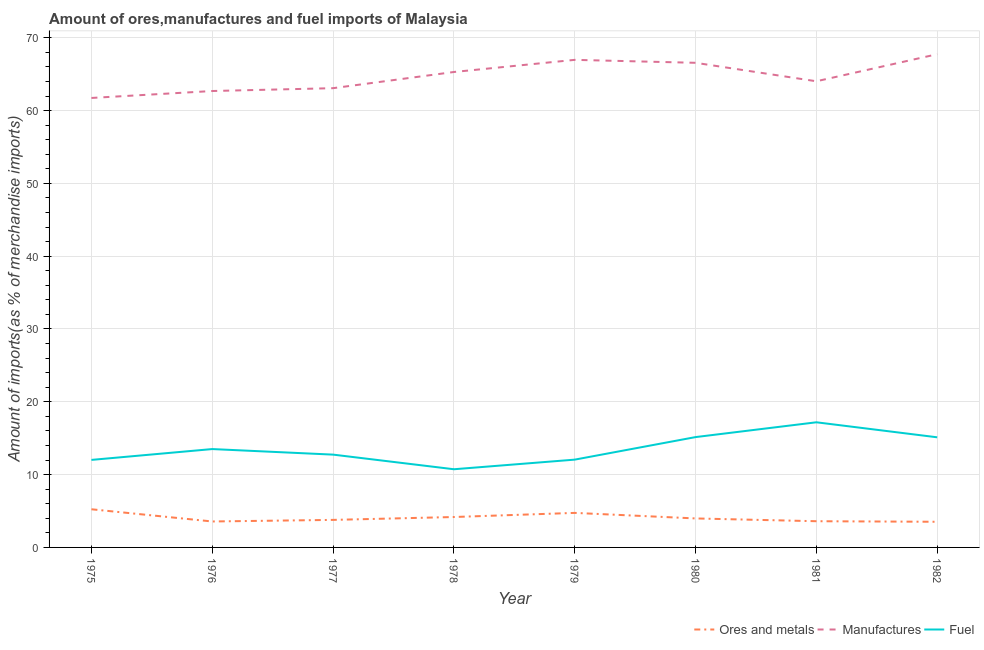What is the percentage of manufactures imports in 1980?
Provide a short and direct response. 66.56. Across all years, what is the maximum percentage of ores and metals imports?
Provide a short and direct response. 5.24. Across all years, what is the minimum percentage of ores and metals imports?
Provide a succinct answer. 3.52. In which year was the percentage of ores and metals imports maximum?
Offer a terse response. 1975. What is the total percentage of ores and metals imports in the graph?
Provide a short and direct response. 32.61. What is the difference between the percentage of fuel imports in 1975 and that in 1978?
Offer a terse response. 1.28. What is the difference between the percentage of fuel imports in 1975 and the percentage of ores and metals imports in 1976?
Provide a short and direct response. 8.46. What is the average percentage of ores and metals imports per year?
Keep it short and to the point. 4.08. In the year 1976, what is the difference between the percentage of fuel imports and percentage of manufactures imports?
Make the answer very short. -49.18. What is the ratio of the percentage of manufactures imports in 1975 to that in 1976?
Provide a short and direct response. 0.98. Is the difference between the percentage of ores and metals imports in 1976 and 1981 greater than the difference between the percentage of manufactures imports in 1976 and 1981?
Ensure brevity in your answer.  Yes. What is the difference between the highest and the second highest percentage of manufactures imports?
Provide a succinct answer. 0.78. What is the difference between the highest and the lowest percentage of ores and metals imports?
Offer a terse response. 1.72. In how many years, is the percentage of manufactures imports greater than the average percentage of manufactures imports taken over all years?
Make the answer very short. 4. Is the sum of the percentage of ores and metals imports in 1978 and 1981 greater than the maximum percentage of manufactures imports across all years?
Offer a very short reply. No. Is it the case that in every year, the sum of the percentage of ores and metals imports and percentage of manufactures imports is greater than the percentage of fuel imports?
Provide a succinct answer. Yes. Is the percentage of fuel imports strictly greater than the percentage of manufactures imports over the years?
Provide a succinct answer. No. Is the percentage of ores and metals imports strictly less than the percentage of manufactures imports over the years?
Give a very brief answer. Yes. What is the difference between two consecutive major ticks on the Y-axis?
Give a very brief answer. 10. How many legend labels are there?
Give a very brief answer. 3. What is the title of the graph?
Provide a succinct answer. Amount of ores,manufactures and fuel imports of Malaysia. What is the label or title of the X-axis?
Make the answer very short. Year. What is the label or title of the Y-axis?
Your answer should be very brief. Amount of imports(as % of merchandise imports). What is the Amount of imports(as % of merchandise imports) in Ores and metals in 1975?
Provide a succinct answer. 5.24. What is the Amount of imports(as % of merchandise imports) in Manufactures in 1975?
Your response must be concise. 61.73. What is the Amount of imports(as % of merchandise imports) of Fuel in 1975?
Give a very brief answer. 12.02. What is the Amount of imports(as % of merchandise imports) of Ores and metals in 1976?
Your answer should be compact. 3.56. What is the Amount of imports(as % of merchandise imports) in Manufactures in 1976?
Offer a terse response. 62.68. What is the Amount of imports(as % of merchandise imports) of Fuel in 1976?
Offer a very short reply. 13.51. What is the Amount of imports(as % of merchandise imports) in Ores and metals in 1977?
Keep it short and to the point. 3.78. What is the Amount of imports(as % of merchandise imports) of Manufactures in 1977?
Provide a succinct answer. 63.07. What is the Amount of imports(as % of merchandise imports) in Fuel in 1977?
Keep it short and to the point. 12.75. What is the Amount of imports(as % of merchandise imports) in Ores and metals in 1978?
Offer a terse response. 4.18. What is the Amount of imports(as % of merchandise imports) of Manufactures in 1978?
Provide a succinct answer. 65.3. What is the Amount of imports(as % of merchandise imports) in Fuel in 1978?
Offer a very short reply. 10.74. What is the Amount of imports(as % of merchandise imports) in Ores and metals in 1979?
Provide a short and direct response. 4.74. What is the Amount of imports(as % of merchandise imports) of Manufactures in 1979?
Your answer should be compact. 66.96. What is the Amount of imports(as % of merchandise imports) in Fuel in 1979?
Your answer should be very brief. 12.06. What is the Amount of imports(as % of merchandise imports) in Ores and metals in 1980?
Keep it short and to the point. 3.98. What is the Amount of imports(as % of merchandise imports) of Manufactures in 1980?
Provide a short and direct response. 66.56. What is the Amount of imports(as % of merchandise imports) in Fuel in 1980?
Give a very brief answer. 15.15. What is the Amount of imports(as % of merchandise imports) of Ores and metals in 1981?
Offer a very short reply. 3.6. What is the Amount of imports(as % of merchandise imports) of Manufactures in 1981?
Your answer should be very brief. 64.02. What is the Amount of imports(as % of merchandise imports) in Fuel in 1981?
Provide a succinct answer. 17.19. What is the Amount of imports(as % of merchandise imports) of Ores and metals in 1982?
Provide a short and direct response. 3.52. What is the Amount of imports(as % of merchandise imports) of Manufactures in 1982?
Keep it short and to the point. 67.74. What is the Amount of imports(as % of merchandise imports) of Fuel in 1982?
Provide a succinct answer. 15.12. Across all years, what is the maximum Amount of imports(as % of merchandise imports) of Ores and metals?
Provide a succinct answer. 5.24. Across all years, what is the maximum Amount of imports(as % of merchandise imports) of Manufactures?
Your answer should be very brief. 67.74. Across all years, what is the maximum Amount of imports(as % of merchandise imports) in Fuel?
Keep it short and to the point. 17.19. Across all years, what is the minimum Amount of imports(as % of merchandise imports) of Ores and metals?
Ensure brevity in your answer.  3.52. Across all years, what is the minimum Amount of imports(as % of merchandise imports) in Manufactures?
Give a very brief answer. 61.73. Across all years, what is the minimum Amount of imports(as % of merchandise imports) of Fuel?
Make the answer very short. 10.74. What is the total Amount of imports(as % of merchandise imports) in Ores and metals in the graph?
Your answer should be very brief. 32.61. What is the total Amount of imports(as % of merchandise imports) of Manufactures in the graph?
Ensure brevity in your answer.  518.08. What is the total Amount of imports(as % of merchandise imports) in Fuel in the graph?
Keep it short and to the point. 108.54. What is the difference between the Amount of imports(as % of merchandise imports) of Ores and metals in 1975 and that in 1976?
Provide a short and direct response. 1.68. What is the difference between the Amount of imports(as % of merchandise imports) in Manufactures in 1975 and that in 1976?
Make the answer very short. -0.95. What is the difference between the Amount of imports(as % of merchandise imports) of Fuel in 1975 and that in 1976?
Ensure brevity in your answer.  -1.49. What is the difference between the Amount of imports(as % of merchandise imports) of Ores and metals in 1975 and that in 1977?
Give a very brief answer. 1.46. What is the difference between the Amount of imports(as % of merchandise imports) in Manufactures in 1975 and that in 1977?
Your response must be concise. -1.34. What is the difference between the Amount of imports(as % of merchandise imports) in Fuel in 1975 and that in 1977?
Your answer should be compact. -0.72. What is the difference between the Amount of imports(as % of merchandise imports) in Ores and metals in 1975 and that in 1978?
Your answer should be very brief. 1.06. What is the difference between the Amount of imports(as % of merchandise imports) in Manufactures in 1975 and that in 1978?
Keep it short and to the point. -3.57. What is the difference between the Amount of imports(as % of merchandise imports) of Fuel in 1975 and that in 1978?
Your response must be concise. 1.28. What is the difference between the Amount of imports(as % of merchandise imports) in Ores and metals in 1975 and that in 1979?
Ensure brevity in your answer.  0.5. What is the difference between the Amount of imports(as % of merchandise imports) in Manufactures in 1975 and that in 1979?
Ensure brevity in your answer.  -5.23. What is the difference between the Amount of imports(as % of merchandise imports) of Fuel in 1975 and that in 1979?
Offer a very short reply. -0.04. What is the difference between the Amount of imports(as % of merchandise imports) of Ores and metals in 1975 and that in 1980?
Ensure brevity in your answer.  1.26. What is the difference between the Amount of imports(as % of merchandise imports) in Manufactures in 1975 and that in 1980?
Provide a short and direct response. -4.83. What is the difference between the Amount of imports(as % of merchandise imports) in Fuel in 1975 and that in 1980?
Make the answer very short. -3.13. What is the difference between the Amount of imports(as % of merchandise imports) of Ores and metals in 1975 and that in 1981?
Offer a very short reply. 1.64. What is the difference between the Amount of imports(as % of merchandise imports) in Manufactures in 1975 and that in 1981?
Keep it short and to the point. -2.29. What is the difference between the Amount of imports(as % of merchandise imports) of Fuel in 1975 and that in 1981?
Give a very brief answer. -5.16. What is the difference between the Amount of imports(as % of merchandise imports) in Ores and metals in 1975 and that in 1982?
Your response must be concise. 1.72. What is the difference between the Amount of imports(as % of merchandise imports) of Manufactures in 1975 and that in 1982?
Offer a terse response. -6.01. What is the difference between the Amount of imports(as % of merchandise imports) in Fuel in 1975 and that in 1982?
Provide a succinct answer. -3.1. What is the difference between the Amount of imports(as % of merchandise imports) of Ores and metals in 1976 and that in 1977?
Ensure brevity in your answer.  -0.22. What is the difference between the Amount of imports(as % of merchandise imports) in Manufactures in 1976 and that in 1977?
Make the answer very short. -0.39. What is the difference between the Amount of imports(as % of merchandise imports) in Fuel in 1976 and that in 1977?
Your answer should be very brief. 0.76. What is the difference between the Amount of imports(as % of merchandise imports) of Ores and metals in 1976 and that in 1978?
Offer a terse response. -0.61. What is the difference between the Amount of imports(as % of merchandise imports) in Manufactures in 1976 and that in 1978?
Make the answer very short. -2.61. What is the difference between the Amount of imports(as % of merchandise imports) in Fuel in 1976 and that in 1978?
Offer a terse response. 2.77. What is the difference between the Amount of imports(as % of merchandise imports) of Ores and metals in 1976 and that in 1979?
Offer a very short reply. -1.18. What is the difference between the Amount of imports(as % of merchandise imports) of Manufactures in 1976 and that in 1979?
Offer a very short reply. -4.28. What is the difference between the Amount of imports(as % of merchandise imports) in Fuel in 1976 and that in 1979?
Provide a short and direct response. 1.45. What is the difference between the Amount of imports(as % of merchandise imports) in Ores and metals in 1976 and that in 1980?
Offer a very short reply. -0.42. What is the difference between the Amount of imports(as % of merchandise imports) in Manufactures in 1976 and that in 1980?
Provide a succinct answer. -3.87. What is the difference between the Amount of imports(as % of merchandise imports) in Fuel in 1976 and that in 1980?
Provide a succinct answer. -1.64. What is the difference between the Amount of imports(as % of merchandise imports) of Ores and metals in 1976 and that in 1981?
Provide a succinct answer. -0.04. What is the difference between the Amount of imports(as % of merchandise imports) of Manufactures in 1976 and that in 1981?
Provide a short and direct response. -1.34. What is the difference between the Amount of imports(as % of merchandise imports) in Fuel in 1976 and that in 1981?
Keep it short and to the point. -3.68. What is the difference between the Amount of imports(as % of merchandise imports) in Ores and metals in 1976 and that in 1982?
Your response must be concise. 0.04. What is the difference between the Amount of imports(as % of merchandise imports) of Manufactures in 1976 and that in 1982?
Provide a short and direct response. -5.06. What is the difference between the Amount of imports(as % of merchandise imports) of Fuel in 1976 and that in 1982?
Give a very brief answer. -1.62. What is the difference between the Amount of imports(as % of merchandise imports) of Ores and metals in 1977 and that in 1978?
Ensure brevity in your answer.  -0.4. What is the difference between the Amount of imports(as % of merchandise imports) in Manufactures in 1977 and that in 1978?
Provide a succinct answer. -2.22. What is the difference between the Amount of imports(as % of merchandise imports) in Fuel in 1977 and that in 1978?
Your answer should be very brief. 2.01. What is the difference between the Amount of imports(as % of merchandise imports) of Ores and metals in 1977 and that in 1979?
Offer a terse response. -0.96. What is the difference between the Amount of imports(as % of merchandise imports) in Manufactures in 1977 and that in 1979?
Offer a terse response. -3.89. What is the difference between the Amount of imports(as % of merchandise imports) in Fuel in 1977 and that in 1979?
Your answer should be compact. 0.69. What is the difference between the Amount of imports(as % of merchandise imports) of Ores and metals in 1977 and that in 1980?
Make the answer very short. -0.2. What is the difference between the Amount of imports(as % of merchandise imports) in Manufactures in 1977 and that in 1980?
Keep it short and to the point. -3.48. What is the difference between the Amount of imports(as % of merchandise imports) in Fuel in 1977 and that in 1980?
Offer a terse response. -2.41. What is the difference between the Amount of imports(as % of merchandise imports) in Ores and metals in 1977 and that in 1981?
Offer a terse response. 0.18. What is the difference between the Amount of imports(as % of merchandise imports) in Manufactures in 1977 and that in 1981?
Make the answer very short. -0.95. What is the difference between the Amount of imports(as % of merchandise imports) in Fuel in 1977 and that in 1981?
Your answer should be compact. -4.44. What is the difference between the Amount of imports(as % of merchandise imports) of Ores and metals in 1977 and that in 1982?
Ensure brevity in your answer.  0.26. What is the difference between the Amount of imports(as % of merchandise imports) in Manufactures in 1977 and that in 1982?
Keep it short and to the point. -4.67. What is the difference between the Amount of imports(as % of merchandise imports) of Fuel in 1977 and that in 1982?
Ensure brevity in your answer.  -2.38. What is the difference between the Amount of imports(as % of merchandise imports) in Ores and metals in 1978 and that in 1979?
Make the answer very short. -0.57. What is the difference between the Amount of imports(as % of merchandise imports) of Manufactures in 1978 and that in 1979?
Offer a terse response. -1.67. What is the difference between the Amount of imports(as % of merchandise imports) in Fuel in 1978 and that in 1979?
Your answer should be very brief. -1.32. What is the difference between the Amount of imports(as % of merchandise imports) of Ores and metals in 1978 and that in 1980?
Offer a very short reply. 0.2. What is the difference between the Amount of imports(as % of merchandise imports) in Manufactures in 1978 and that in 1980?
Make the answer very short. -1.26. What is the difference between the Amount of imports(as % of merchandise imports) of Fuel in 1978 and that in 1980?
Offer a terse response. -4.42. What is the difference between the Amount of imports(as % of merchandise imports) of Ores and metals in 1978 and that in 1981?
Your answer should be compact. 0.58. What is the difference between the Amount of imports(as % of merchandise imports) in Manufactures in 1978 and that in 1981?
Your response must be concise. 1.28. What is the difference between the Amount of imports(as % of merchandise imports) in Fuel in 1978 and that in 1981?
Your answer should be very brief. -6.45. What is the difference between the Amount of imports(as % of merchandise imports) in Ores and metals in 1978 and that in 1982?
Make the answer very short. 0.65. What is the difference between the Amount of imports(as % of merchandise imports) of Manufactures in 1978 and that in 1982?
Offer a terse response. -2.44. What is the difference between the Amount of imports(as % of merchandise imports) of Fuel in 1978 and that in 1982?
Provide a short and direct response. -4.39. What is the difference between the Amount of imports(as % of merchandise imports) of Ores and metals in 1979 and that in 1980?
Offer a very short reply. 0.76. What is the difference between the Amount of imports(as % of merchandise imports) in Manufactures in 1979 and that in 1980?
Your answer should be compact. 0.41. What is the difference between the Amount of imports(as % of merchandise imports) of Fuel in 1979 and that in 1980?
Keep it short and to the point. -3.1. What is the difference between the Amount of imports(as % of merchandise imports) of Ores and metals in 1979 and that in 1981?
Provide a short and direct response. 1.14. What is the difference between the Amount of imports(as % of merchandise imports) in Manufactures in 1979 and that in 1981?
Your answer should be compact. 2.94. What is the difference between the Amount of imports(as % of merchandise imports) of Fuel in 1979 and that in 1981?
Your answer should be very brief. -5.13. What is the difference between the Amount of imports(as % of merchandise imports) in Ores and metals in 1979 and that in 1982?
Your answer should be compact. 1.22. What is the difference between the Amount of imports(as % of merchandise imports) of Manufactures in 1979 and that in 1982?
Give a very brief answer. -0.78. What is the difference between the Amount of imports(as % of merchandise imports) of Fuel in 1979 and that in 1982?
Your response must be concise. -3.07. What is the difference between the Amount of imports(as % of merchandise imports) in Ores and metals in 1980 and that in 1981?
Offer a terse response. 0.38. What is the difference between the Amount of imports(as % of merchandise imports) in Manufactures in 1980 and that in 1981?
Keep it short and to the point. 2.54. What is the difference between the Amount of imports(as % of merchandise imports) of Fuel in 1980 and that in 1981?
Offer a very short reply. -2.03. What is the difference between the Amount of imports(as % of merchandise imports) in Ores and metals in 1980 and that in 1982?
Offer a very short reply. 0.46. What is the difference between the Amount of imports(as % of merchandise imports) of Manufactures in 1980 and that in 1982?
Your answer should be compact. -1.18. What is the difference between the Amount of imports(as % of merchandise imports) in Fuel in 1980 and that in 1982?
Provide a succinct answer. 0.03. What is the difference between the Amount of imports(as % of merchandise imports) of Ores and metals in 1981 and that in 1982?
Give a very brief answer. 0.08. What is the difference between the Amount of imports(as % of merchandise imports) in Manufactures in 1981 and that in 1982?
Your response must be concise. -3.72. What is the difference between the Amount of imports(as % of merchandise imports) in Fuel in 1981 and that in 1982?
Give a very brief answer. 2.06. What is the difference between the Amount of imports(as % of merchandise imports) in Ores and metals in 1975 and the Amount of imports(as % of merchandise imports) in Manufactures in 1976?
Ensure brevity in your answer.  -57.44. What is the difference between the Amount of imports(as % of merchandise imports) in Ores and metals in 1975 and the Amount of imports(as % of merchandise imports) in Fuel in 1976?
Give a very brief answer. -8.27. What is the difference between the Amount of imports(as % of merchandise imports) of Manufactures in 1975 and the Amount of imports(as % of merchandise imports) of Fuel in 1976?
Offer a terse response. 48.22. What is the difference between the Amount of imports(as % of merchandise imports) of Ores and metals in 1975 and the Amount of imports(as % of merchandise imports) of Manufactures in 1977?
Make the answer very short. -57.83. What is the difference between the Amount of imports(as % of merchandise imports) in Ores and metals in 1975 and the Amount of imports(as % of merchandise imports) in Fuel in 1977?
Offer a terse response. -7.5. What is the difference between the Amount of imports(as % of merchandise imports) in Manufactures in 1975 and the Amount of imports(as % of merchandise imports) in Fuel in 1977?
Your answer should be very brief. 48.98. What is the difference between the Amount of imports(as % of merchandise imports) of Ores and metals in 1975 and the Amount of imports(as % of merchandise imports) of Manufactures in 1978?
Your answer should be very brief. -60.06. What is the difference between the Amount of imports(as % of merchandise imports) in Ores and metals in 1975 and the Amount of imports(as % of merchandise imports) in Fuel in 1978?
Your answer should be compact. -5.5. What is the difference between the Amount of imports(as % of merchandise imports) in Manufactures in 1975 and the Amount of imports(as % of merchandise imports) in Fuel in 1978?
Make the answer very short. 50.99. What is the difference between the Amount of imports(as % of merchandise imports) of Ores and metals in 1975 and the Amount of imports(as % of merchandise imports) of Manufactures in 1979?
Make the answer very short. -61.72. What is the difference between the Amount of imports(as % of merchandise imports) in Ores and metals in 1975 and the Amount of imports(as % of merchandise imports) in Fuel in 1979?
Keep it short and to the point. -6.82. What is the difference between the Amount of imports(as % of merchandise imports) in Manufactures in 1975 and the Amount of imports(as % of merchandise imports) in Fuel in 1979?
Your response must be concise. 49.67. What is the difference between the Amount of imports(as % of merchandise imports) in Ores and metals in 1975 and the Amount of imports(as % of merchandise imports) in Manufactures in 1980?
Your answer should be very brief. -61.32. What is the difference between the Amount of imports(as % of merchandise imports) in Ores and metals in 1975 and the Amount of imports(as % of merchandise imports) in Fuel in 1980?
Your answer should be compact. -9.91. What is the difference between the Amount of imports(as % of merchandise imports) of Manufactures in 1975 and the Amount of imports(as % of merchandise imports) of Fuel in 1980?
Ensure brevity in your answer.  46.58. What is the difference between the Amount of imports(as % of merchandise imports) in Ores and metals in 1975 and the Amount of imports(as % of merchandise imports) in Manufactures in 1981?
Your answer should be very brief. -58.78. What is the difference between the Amount of imports(as % of merchandise imports) in Ores and metals in 1975 and the Amount of imports(as % of merchandise imports) in Fuel in 1981?
Ensure brevity in your answer.  -11.95. What is the difference between the Amount of imports(as % of merchandise imports) of Manufactures in 1975 and the Amount of imports(as % of merchandise imports) of Fuel in 1981?
Your answer should be very brief. 44.54. What is the difference between the Amount of imports(as % of merchandise imports) of Ores and metals in 1975 and the Amount of imports(as % of merchandise imports) of Manufactures in 1982?
Make the answer very short. -62.5. What is the difference between the Amount of imports(as % of merchandise imports) in Ores and metals in 1975 and the Amount of imports(as % of merchandise imports) in Fuel in 1982?
Give a very brief answer. -9.88. What is the difference between the Amount of imports(as % of merchandise imports) in Manufactures in 1975 and the Amount of imports(as % of merchandise imports) in Fuel in 1982?
Keep it short and to the point. 46.61. What is the difference between the Amount of imports(as % of merchandise imports) of Ores and metals in 1976 and the Amount of imports(as % of merchandise imports) of Manufactures in 1977?
Your response must be concise. -59.51. What is the difference between the Amount of imports(as % of merchandise imports) in Ores and metals in 1976 and the Amount of imports(as % of merchandise imports) in Fuel in 1977?
Your answer should be very brief. -9.18. What is the difference between the Amount of imports(as % of merchandise imports) of Manufactures in 1976 and the Amount of imports(as % of merchandise imports) of Fuel in 1977?
Provide a succinct answer. 49.94. What is the difference between the Amount of imports(as % of merchandise imports) in Ores and metals in 1976 and the Amount of imports(as % of merchandise imports) in Manufactures in 1978?
Your answer should be compact. -61.73. What is the difference between the Amount of imports(as % of merchandise imports) in Ores and metals in 1976 and the Amount of imports(as % of merchandise imports) in Fuel in 1978?
Offer a very short reply. -7.17. What is the difference between the Amount of imports(as % of merchandise imports) of Manufactures in 1976 and the Amount of imports(as % of merchandise imports) of Fuel in 1978?
Provide a short and direct response. 51.95. What is the difference between the Amount of imports(as % of merchandise imports) of Ores and metals in 1976 and the Amount of imports(as % of merchandise imports) of Manufactures in 1979?
Your answer should be compact. -63.4. What is the difference between the Amount of imports(as % of merchandise imports) of Ores and metals in 1976 and the Amount of imports(as % of merchandise imports) of Fuel in 1979?
Keep it short and to the point. -8.49. What is the difference between the Amount of imports(as % of merchandise imports) in Manufactures in 1976 and the Amount of imports(as % of merchandise imports) in Fuel in 1979?
Your response must be concise. 50.63. What is the difference between the Amount of imports(as % of merchandise imports) of Ores and metals in 1976 and the Amount of imports(as % of merchandise imports) of Manufactures in 1980?
Offer a very short reply. -63. What is the difference between the Amount of imports(as % of merchandise imports) of Ores and metals in 1976 and the Amount of imports(as % of merchandise imports) of Fuel in 1980?
Provide a short and direct response. -11.59. What is the difference between the Amount of imports(as % of merchandise imports) in Manufactures in 1976 and the Amount of imports(as % of merchandise imports) in Fuel in 1980?
Keep it short and to the point. 47.53. What is the difference between the Amount of imports(as % of merchandise imports) of Ores and metals in 1976 and the Amount of imports(as % of merchandise imports) of Manufactures in 1981?
Your response must be concise. -60.46. What is the difference between the Amount of imports(as % of merchandise imports) of Ores and metals in 1976 and the Amount of imports(as % of merchandise imports) of Fuel in 1981?
Ensure brevity in your answer.  -13.62. What is the difference between the Amount of imports(as % of merchandise imports) in Manufactures in 1976 and the Amount of imports(as % of merchandise imports) in Fuel in 1981?
Make the answer very short. 45.5. What is the difference between the Amount of imports(as % of merchandise imports) of Ores and metals in 1976 and the Amount of imports(as % of merchandise imports) of Manufactures in 1982?
Your response must be concise. -64.18. What is the difference between the Amount of imports(as % of merchandise imports) of Ores and metals in 1976 and the Amount of imports(as % of merchandise imports) of Fuel in 1982?
Ensure brevity in your answer.  -11.56. What is the difference between the Amount of imports(as % of merchandise imports) in Manufactures in 1976 and the Amount of imports(as % of merchandise imports) in Fuel in 1982?
Make the answer very short. 47.56. What is the difference between the Amount of imports(as % of merchandise imports) in Ores and metals in 1977 and the Amount of imports(as % of merchandise imports) in Manufactures in 1978?
Your answer should be compact. -61.52. What is the difference between the Amount of imports(as % of merchandise imports) of Ores and metals in 1977 and the Amount of imports(as % of merchandise imports) of Fuel in 1978?
Give a very brief answer. -6.96. What is the difference between the Amount of imports(as % of merchandise imports) in Manufactures in 1977 and the Amount of imports(as % of merchandise imports) in Fuel in 1978?
Offer a very short reply. 52.34. What is the difference between the Amount of imports(as % of merchandise imports) of Ores and metals in 1977 and the Amount of imports(as % of merchandise imports) of Manufactures in 1979?
Offer a terse response. -63.18. What is the difference between the Amount of imports(as % of merchandise imports) of Ores and metals in 1977 and the Amount of imports(as % of merchandise imports) of Fuel in 1979?
Your answer should be compact. -8.28. What is the difference between the Amount of imports(as % of merchandise imports) of Manufactures in 1977 and the Amount of imports(as % of merchandise imports) of Fuel in 1979?
Your response must be concise. 51.02. What is the difference between the Amount of imports(as % of merchandise imports) of Ores and metals in 1977 and the Amount of imports(as % of merchandise imports) of Manufactures in 1980?
Your answer should be compact. -62.78. What is the difference between the Amount of imports(as % of merchandise imports) in Ores and metals in 1977 and the Amount of imports(as % of merchandise imports) in Fuel in 1980?
Make the answer very short. -11.37. What is the difference between the Amount of imports(as % of merchandise imports) in Manufactures in 1977 and the Amount of imports(as % of merchandise imports) in Fuel in 1980?
Provide a succinct answer. 47.92. What is the difference between the Amount of imports(as % of merchandise imports) of Ores and metals in 1977 and the Amount of imports(as % of merchandise imports) of Manufactures in 1981?
Give a very brief answer. -60.24. What is the difference between the Amount of imports(as % of merchandise imports) in Ores and metals in 1977 and the Amount of imports(as % of merchandise imports) in Fuel in 1981?
Make the answer very short. -13.41. What is the difference between the Amount of imports(as % of merchandise imports) in Manufactures in 1977 and the Amount of imports(as % of merchandise imports) in Fuel in 1981?
Your answer should be very brief. 45.89. What is the difference between the Amount of imports(as % of merchandise imports) of Ores and metals in 1977 and the Amount of imports(as % of merchandise imports) of Manufactures in 1982?
Make the answer very short. -63.96. What is the difference between the Amount of imports(as % of merchandise imports) in Ores and metals in 1977 and the Amount of imports(as % of merchandise imports) in Fuel in 1982?
Your answer should be very brief. -11.34. What is the difference between the Amount of imports(as % of merchandise imports) of Manufactures in 1977 and the Amount of imports(as % of merchandise imports) of Fuel in 1982?
Make the answer very short. 47.95. What is the difference between the Amount of imports(as % of merchandise imports) in Ores and metals in 1978 and the Amount of imports(as % of merchandise imports) in Manufactures in 1979?
Provide a succinct answer. -62.79. What is the difference between the Amount of imports(as % of merchandise imports) of Ores and metals in 1978 and the Amount of imports(as % of merchandise imports) of Fuel in 1979?
Make the answer very short. -7.88. What is the difference between the Amount of imports(as % of merchandise imports) in Manufactures in 1978 and the Amount of imports(as % of merchandise imports) in Fuel in 1979?
Provide a short and direct response. 53.24. What is the difference between the Amount of imports(as % of merchandise imports) of Ores and metals in 1978 and the Amount of imports(as % of merchandise imports) of Manufactures in 1980?
Provide a short and direct response. -62.38. What is the difference between the Amount of imports(as % of merchandise imports) of Ores and metals in 1978 and the Amount of imports(as % of merchandise imports) of Fuel in 1980?
Offer a very short reply. -10.98. What is the difference between the Amount of imports(as % of merchandise imports) of Manufactures in 1978 and the Amount of imports(as % of merchandise imports) of Fuel in 1980?
Provide a succinct answer. 50.14. What is the difference between the Amount of imports(as % of merchandise imports) in Ores and metals in 1978 and the Amount of imports(as % of merchandise imports) in Manufactures in 1981?
Keep it short and to the point. -59.85. What is the difference between the Amount of imports(as % of merchandise imports) in Ores and metals in 1978 and the Amount of imports(as % of merchandise imports) in Fuel in 1981?
Give a very brief answer. -13.01. What is the difference between the Amount of imports(as % of merchandise imports) of Manufactures in 1978 and the Amount of imports(as % of merchandise imports) of Fuel in 1981?
Keep it short and to the point. 48.11. What is the difference between the Amount of imports(as % of merchandise imports) of Ores and metals in 1978 and the Amount of imports(as % of merchandise imports) of Manufactures in 1982?
Keep it short and to the point. -63.56. What is the difference between the Amount of imports(as % of merchandise imports) of Ores and metals in 1978 and the Amount of imports(as % of merchandise imports) of Fuel in 1982?
Provide a succinct answer. -10.95. What is the difference between the Amount of imports(as % of merchandise imports) of Manufactures in 1978 and the Amount of imports(as % of merchandise imports) of Fuel in 1982?
Make the answer very short. 50.17. What is the difference between the Amount of imports(as % of merchandise imports) of Ores and metals in 1979 and the Amount of imports(as % of merchandise imports) of Manufactures in 1980?
Ensure brevity in your answer.  -61.82. What is the difference between the Amount of imports(as % of merchandise imports) of Ores and metals in 1979 and the Amount of imports(as % of merchandise imports) of Fuel in 1980?
Keep it short and to the point. -10.41. What is the difference between the Amount of imports(as % of merchandise imports) of Manufactures in 1979 and the Amount of imports(as % of merchandise imports) of Fuel in 1980?
Ensure brevity in your answer.  51.81. What is the difference between the Amount of imports(as % of merchandise imports) in Ores and metals in 1979 and the Amount of imports(as % of merchandise imports) in Manufactures in 1981?
Offer a very short reply. -59.28. What is the difference between the Amount of imports(as % of merchandise imports) of Ores and metals in 1979 and the Amount of imports(as % of merchandise imports) of Fuel in 1981?
Give a very brief answer. -12.44. What is the difference between the Amount of imports(as % of merchandise imports) in Manufactures in 1979 and the Amount of imports(as % of merchandise imports) in Fuel in 1981?
Offer a terse response. 49.78. What is the difference between the Amount of imports(as % of merchandise imports) of Ores and metals in 1979 and the Amount of imports(as % of merchandise imports) of Manufactures in 1982?
Your answer should be compact. -63. What is the difference between the Amount of imports(as % of merchandise imports) of Ores and metals in 1979 and the Amount of imports(as % of merchandise imports) of Fuel in 1982?
Ensure brevity in your answer.  -10.38. What is the difference between the Amount of imports(as % of merchandise imports) in Manufactures in 1979 and the Amount of imports(as % of merchandise imports) in Fuel in 1982?
Provide a short and direct response. 51.84. What is the difference between the Amount of imports(as % of merchandise imports) in Ores and metals in 1980 and the Amount of imports(as % of merchandise imports) in Manufactures in 1981?
Make the answer very short. -60.04. What is the difference between the Amount of imports(as % of merchandise imports) in Ores and metals in 1980 and the Amount of imports(as % of merchandise imports) in Fuel in 1981?
Keep it short and to the point. -13.21. What is the difference between the Amount of imports(as % of merchandise imports) in Manufactures in 1980 and the Amount of imports(as % of merchandise imports) in Fuel in 1981?
Ensure brevity in your answer.  49.37. What is the difference between the Amount of imports(as % of merchandise imports) in Ores and metals in 1980 and the Amount of imports(as % of merchandise imports) in Manufactures in 1982?
Your response must be concise. -63.76. What is the difference between the Amount of imports(as % of merchandise imports) of Ores and metals in 1980 and the Amount of imports(as % of merchandise imports) of Fuel in 1982?
Your answer should be very brief. -11.14. What is the difference between the Amount of imports(as % of merchandise imports) of Manufactures in 1980 and the Amount of imports(as % of merchandise imports) of Fuel in 1982?
Your answer should be compact. 51.43. What is the difference between the Amount of imports(as % of merchandise imports) in Ores and metals in 1981 and the Amount of imports(as % of merchandise imports) in Manufactures in 1982?
Your response must be concise. -64.14. What is the difference between the Amount of imports(as % of merchandise imports) in Ores and metals in 1981 and the Amount of imports(as % of merchandise imports) in Fuel in 1982?
Your answer should be very brief. -11.53. What is the difference between the Amount of imports(as % of merchandise imports) of Manufactures in 1981 and the Amount of imports(as % of merchandise imports) of Fuel in 1982?
Your answer should be very brief. 48.9. What is the average Amount of imports(as % of merchandise imports) of Ores and metals per year?
Ensure brevity in your answer.  4.08. What is the average Amount of imports(as % of merchandise imports) in Manufactures per year?
Provide a succinct answer. 64.76. What is the average Amount of imports(as % of merchandise imports) of Fuel per year?
Ensure brevity in your answer.  13.57. In the year 1975, what is the difference between the Amount of imports(as % of merchandise imports) in Ores and metals and Amount of imports(as % of merchandise imports) in Manufactures?
Provide a short and direct response. -56.49. In the year 1975, what is the difference between the Amount of imports(as % of merchandise imports) of Ores and metals and Amount of imports(as % of merchandise imports) of Fuel?
Keep it short and to the point. -6.78. In the year 1975, what is the difference between the Amount of imports(as % of merchandise imports) of Manufactures and Amount of imports(as % of merchandise imports) of Fuel?
Provide a succinct answer. 49.71. In the year 1976, what is the difference between the Amount of imports(as % of merchandise imports) of Ores and metals and Amount of imports(as % of merchandise imports) of Manufactures?
Your answer should be compact. -59.12. In the year 1976, what is the difference between the Amount of imports(as % of merchandise imports) in Ores and metals and Amount of imports(as % of merchandise imports) in Fuel?
Provide a succinct answer. -9.95. In the year 1976, what is the difference between the Amount of imports(as % of merchandise imports) of Manufactures and Amount of imports(as % of merchandise imports) of Fuel?
Provide a short and direct response. 49.18. In the year 1977, what is the difference between the Amount of imports(as % of merchandise imports) in Ores and metals and Amount of imports(as % of merchandise imports) in Manufactures?
Your answer should be compact. -59.29. In the year 1977, what is the difference between the Amount of imports(as % of merchandise imports) in Ores and metals and Amount of imports(as % of merchandise imports) in Fuel?
Offer a terse response. -8.96. In the year 1977, what is the difference between the Amount of imports(as % of merchandise imports) of Manufactures and Amount of imports(as % of merchandise imports) of Fuel?
Ensure brevity in your answer.  50.33. In the year 1978, what is the difference between the Amount of imports(as % of merchandise imports) of Ores and metals and Amount of imports(as % of merchandise imports) of Manufactures?
Provide a succinct answer. -61.12. In the year 1978, what is the difference between the Amount of imports(as % of merchandise imports) of Ores and metals and Amount of imports(as % of merchandise imports) of Fuel?
Provide a succinct answer. -6.56. In the year 1978, what is the difference between the Amount of imports(as % of merchandise imports) of Manufactures and Amount of imports(as % of merchandise imports) of Fuel?
Provide a short and direct response. 54.56. In the year 1979, what is the difference between the Amount of imports(as % of merchandise imports) in Ores and metals and Amount of imports(as % of merchandise imports) in Manufactures?
Make the answer very short. -62.22. In the year 1979, what is the difference between the Amount of imports(as % of merchandise imports) of Ores and metals and Amount of imports(as % of merchandise imports) of Fuel?
Give a very brief answer. -7.31. In the year 1979, what is the difference between the Amount of imports(as % of merchandise imports) of Manufactures and Amount of imports(as % of merchandise imports) of Fuel?
Provide a short and direct response. 54.91. In the year 1980, what is the difference between the Amount of imports(as % of merchandise imports) of Ores and metals and Amount of imports(as % of merchandise imports) of Manufactures?
Make the answer very short. -62.58. In the year 1980, what is the difference between the Amount of imports(as % of merchandise imports) in Ores and metals and Amount of imports(as % of merchandise imports) in Fuel?
Provide a succinct answer. -11.17. In the year 1980, what is the difference between the Amount of imports(as % of merchandise imports) in Manufactures and Amount of imports(as % of merchandise imports) in Fuel?
Give a very brief answer. 51.41. In the year 1981, what is the difference between the Amount of imports(as % of merchandise imports) of Ores and metals and Amount of imports(as % of merchandise imports) of Manufactures?
Keep it short and to the point. -60.42. In the year 1981, what is the difference between the Amount of imports(as % of merchandise imports) of Ores and metals and Amount of imports(as % of merchandise imports) of Fuel?
Ensure brevity in your answer.  -13.59. In the year 1981, what is the difference between the Amount of imports(as % of merchandise imports) of Manufactures and Amount of imports(as % of merchandise imports) of Fuel?
Offer a terse response. 46.84. In the year 1982, what is the difference between the Amount of imports(as % of merchandise imports) of Ores and metals and Amount of imports(as % of merchandise imports) of Manufactures?
Offer a very short reply. -64.22. In the year 1982, what is the difference between the Amount of imports(as % of merchandise imports) in Ores and metals and Amount of imports(as % of merchandise imports) in Fuel?
Provide a short and direct response. -11.6. In the year 1982, what is the difference between the Amount of imports(as % of merchandise imports) in Manufactures and Amount of imports(as % of merchandise imports) in Fuel?
Make the answer very short. 52.62. What is the ratio of the Amount of imports(as % of merchandise imports) in Ores and metals in 1975 to that in 1976?
Ensure brevity in your answer.  1.47. What is the ratio of the Amount of imports(as % of merchandise imports) in Fuel in 1975 to that in 1976?
Provide a short and direct response. 0.89. What is the ratio of the Amount of imports(as % of merchandise imports) in Ores and metals in 1975 to that in 1977?
Ensure brevity in your answer.  1.39. What is the ratio of the Amount of imports(as % of merchandise imports) in Manufactures in 1975 to that in 1977?
Offer a terse response. 0.98. What is the ratio of the Amount of imports(as % of merchandise imports) in Fuel in 1975 to that in 1977?
Offer a terse response. 0.94. What is the ratio of the Amount of imports(as % of merchandise imports) of Ores and metals in 1975 to that in 1978?
Your answer should be very brief. 1.25. What is the ratio of the Amount of imports(as % of merchandise imports) of Manufactures in 1975 to that in 1978?
Offer a very short reply. 0.95. What is the ratio of the Amount of imports(as % of merchandise imports) of Fuel in 1975 to that in 1978?
Keep it short and to the point. 1.12. What is the ratio of the Amount of imports(as % of merchandise imports) in Ores and metals in 1975 to that in 1979?
Your response must be concise. 1.1. What is the ratio of the Amount of imports(as % of merchandise imports) in Manufactures in 1975 to that in 1979?
Your answer should be very brief. 0.92. What is the ratio of the Amount of imports(as % of merchandise imports) of Ores and metals in 1975 to that in 1980?
Give a very brief answer. 1.32. What is the ratio of the Amount of imports(as % of merchandise imports) in Manufactures in 1975 to that in 1980?
Keep it short and to the point. 0.93. What is the ratio of the Amount of imports(as % of merchandise imports) of Fuel in 1975 to that in 1980?
Give a very brief answer. 0.79. What is the ratio of the Amount of imports(as % of merchandise imports) in Ores and metals in 1975 to that in 1981?
Provide a short and direct response. 1.46. What is the ratio of the Amount of imports(as % of merchandise imports) in Manufactures in 1975 to that in 1981?
Offer a terse response. 0.96. What is the ratio of the Amount of imports(as % of merchandise imports) in Fuel in 1975 to that in 1981?
Your answer should be very brief. 0.7. What is the ratio of the Amount of imports(as % of merchandise imports) in Ores and metals in 1975 to that in 1982?
Keep it short and to the point. 1.49. What is the ratio of the Amount of imports(as % of merchandise imports) in Manufactures in 1975 to that in 1982?
Provide a short and direct response. 0.91. What is the ratio of the Amount of imports(as % of merchandise imports) of Fuel in 1975 to that in 1982?
Offer a terse response. 0.79. What is the ratio of the Amount of imports(as % of merchandise imports) of Ores and metals in 1976 to that in 1977?
Ensure brevity in your answer.  0.94. What is the ratio of the Amount of imports(as % of merchandise imports) of Manufactures in 1976 to that in 1977?
Offer a very short reply. 0.99. What is the ratio of the Amount of imports(as % of merchandise imports) of Fuel in 1976 to that in 1977?
Provide a succinct answer. 1.06. What is the ratio of the Amount of imports(as % of merchandise imports) in Ores and metals in 1976 to that in 1978?
Ensure brevity in your answer.  0.85. What is the ratio of the Amount of imports(as % of merchandise imports) in Manufactures in 1976 to that in 1978?
Offer a terse response. 0.96. What is the ratio of the Amount of imports(as % of merchandise imports) of Fuel in 1976 to that in 1978?
Give a very brief answer. 1.26. What is the ratio of the Amount of imports(as % of merchandise imports) in Ores and metals in 1976 to that in 1979?
Keep it short and to the point. 0.75. What is the ratio of the Amount of imports(as % of merchandise imports) in Manufactures in 1976 to that in 1979?
Your response must be concise. 0.94. What is the ratio of the Amount of imports(as % of merchandise imports) of Fuel in 1976 to that in 1979?
Make the answer very short. 1.12. What is the ratio of the Amount of imports(as % of merchandise imports) in Ores and metals in 1976 to that in 1980?
Keep it short and to the point. 0.9. What is the ratio of the Amount of imports(as % of merchandise imports) in Manufactures in 1976 to that in 1980?
Provide a succinct answer. 0.94. What is the ratio of the Amount of imports(as % of merchandise imports) of Fuel in 1976 to that in 1980?
Offer a very short reply. 0.89. What is the ratio of the Amount of imports(as % of merchandise imports) in Ores and metals in 1976 to that in 1981?
Make the answer very short. 0.99. What is the ratio of the Amount of imports(as % of merchandise imports) in Manufactures in 1976 to that in 1981?
Offer a terse response. 0.98. What is the ratio of the Amount of imports(as % of merchandise imports) of Fuel in 1976 to that in 1981?
Make the answer very short. 0.79. What is the ratio of the Amount of imports(as % of merchandise imports) of Ores and metals in 1976 to that in 1982?
Your response must be concise. 1.01. What is the ratio of the Amount of imports(as % of merchandise imports) of Manufactures in 1976 to that in 1982?
Offer a very short reply. 0.93. What is the ratio of the Amount of imports(as % of merchandise imports) in Fuel in 1976 to that in 1982?
Make the answer very short. 0.89. What is the ratio of the Amount of imports(as % of merchandise imports) of Ores and metals in 1977 to that in 1978?
Your answer should be very brief. 0.91. What is the ratio of the Amount of imports(as % of merchandise imports) in Manufactures in 1977 to that in 1978?
Offer a terse response. 0.97. What is the ratio of the Amount of imports(as % of merchandise imports) of Fuel in 1977 to that in 1978?
Keep it short and to the point. 1.19. What is the ratio of the Amount of imports(as % of merchandise imports) of Ores and metals in 1977 to that in 1979?
Ensure brevity in your answer.  0.8. What is the ratio of the Amount of imports(as % of merchandise imports) in Manufactures in 1977 to that in 1979?
Ensure brevity in your answer.  0.94. What is the ratio of the Amount of imports(as % of merchandise imports) of Fuel in 1977 to that in 1979?
Offer a terse response. 1.06. What is the ratio of the Amount of imports(as % of merchandise imports) in Ores and metals in 1977 to that in 1980?
Offer a terse response. 0.95. What is the ratio of the Amount of imports(as % of merchandise imports) of Manufactures in 1977 to that in 1980?
Provide a succinct answer. 0.95. What is the ratio of the Amount of imports(as % of merchandise imports) in Fuel in 1977 to that in 1980?
Provide a succinct answer. 0.84. What is the ratio of the Amount of imports(as % of merchandise imports) in Ores and metals in 1977 to that in 1981?
Your response must be concise. 1.05. What is the ratio of the Amount of imports(as % of merchandise imports) of Manufactures in 1977 to that in 1981?
Your answer should be very brief. 0.99. What is the ratio of the Amount of imports(as % of merchandise imports) of Fuel in 1977 to that in 1981?
Make the answer very short. 0.74. What is the ratio of the Amount of imports(as % of merchandise imports) in Ores and metals in 1977 to that in 1982?
Keep it short and to the point. 1.07. What is the ratio of the Amount of imports(as % of merchandise imports) of Manufactures in 1977 to that in 1982?
Your response must be concise. 0.93. What is the ratio of the Amount of imports(as % of merchandise imports) of Fuel in 1977 to that in 1982?
Your answer should be compact. 0.84. What is the ratio of the Amount of imports(as % of merchandise imports) of Ores and metals in 1978 to that in 1979?
Your answer should be compact. 0.88. What is the ratio of the Amount of imports(as % of merchandise imports) of Manufactures in 1978 to that in 1979?
Provide a short and direct response. 0.98. What is the ratio of the Amount of imports(as % of merchandise imports) of Fuel in 1978 to that in 1979?
Your response must be concise. 0.89. What is the ratio of the Amount of imports(as % of merchandise imports) in Ores and metals in 1978 to that in 1980?
Provide a succinct answer. 1.05. What is the ratio of the Amount of imports(as % of merchandise imports) in Manufactures in 1978 to that in 1980?
Your answer should be compact. 0.98. What is the ratio of the Amount of imports(as % of merchandise imports) in Fuel in 1978 to that in 1980?
Offer a terse response. 0.71. What is the ratio of the Amount of imports(as % of merchandise imports) of Ores and metals in 1978 to that in 1981?
Provide a succinct answer. 1.16. What is the ratio of the Amount of imports(as % of merchandise imports) in Manufactures in 1978 to that in 1981?
Your answer should be compact. 1.02. What is the ratio of the Amount of imports(as % of merchandise imports) of Fuel in 1978 to that in 1981?
Make the answer very short. 0.62. What is the ratio of the Amount of imports(as % of merchandise imports) of Ores and metals in 1978 to that in 1982?
Offer a terse response. 1.19. What is the ratio of the Amount of imports(as % of merchandise imports) in Manufactures in 1978 to that in 1982?
Make the answer very short. 0.96. What is the ratio of the Amount of imports(as % of merchandise imports) of Fuel in 1978 to that in 1982?
Keep it short and to the point. 0.71. What is the ratio of the Amount of imports(as % of merchandise imports) of Ores and metals in 1979 to that in 1980?
Ensure brevity in your answer.  1.19. What is the ratio of the Amount of imports(as % of merchandise imports) of Manufactures in 1979 to that in 1980?
Give a very brief answer. 1.01. What is the ratio of the Amount of imports(as % of merchandise imports) of Fuel in 1979 to that in 1980?
Make the answer very short. 0.8. What is the ratio of the Amount of imports(as % of merchandise imports) in Ores and metals in 1979 to that in 1981?
Provide a short and direct response. 1.32. What is the ratio of the Amount of imports(as % of merchandise imports) in Manufactures in 1979 to that in 1981?
Provide a short and direct response. 1.05. What is the ratio of the Amount of imports(as % of merchandise imports) of Fuel in 1979 to that in 1981?
Ensure brevity in your answer.  0.7. What is the ratio of the Amount of imports(as % of merchandise imports) in Ores and metals in 1979 to that in 1982?
Your response must be concise. 1.35. What is the ratio of the Amount of imports(as % of merchandise imports) in Manufactures in 1979 to that in 1982?
Provide a short and direct response. 0.99. What is the ratio of the Amount of imports(as % of merchandise imports) of Fuel in 1979 to that in 1982?
Your answer should be very brief. 0.8. What is the ratio of the Amount of imports(as % of merchandise imports) of Ores and metals in 1980 to that in 1981?
Your answer should be very brief. 1.11. What is the ratio of the Amount of imports(as % of merchandise imports) of Manufactures in 1980 to that in 1981?
Your response must be concise. 1.04. What is the ratio of the Amount of imports(as % of merchandise imports) in Fuel in 1980 to that in 1981?
Provide a succinct answer. 0.88. What is the ratio of the Amount of imports(as % of merchandise imports) of Ores and metals in 1980 to that in 1982?
Your answer should be compact. 1.13. What is the ratio of the Amount of imports(as % of merchandise imports) in Manufactures in 1980 to that in 1982?
Make the answer very short. 0.98. What is the ratio of the Amount of imports(as % of merchandise imports) of Ores and metals in 1981 to that in 1982?
Offer a very short reply. 1.02. What is the ratio of the Amount of imports(as % of merchandise imports) in Manufactures in 1981 to that in 1982?
Keep it short and to the point. 0.95. What is the ratio of the Amount of imports(as % of merchandise imports) of Fuel in 1981 to that in 1982?
Provide a succinct answer. 1.14. What is the difference between the highest and the second highest Amount of imports(as % of merchandise imports) in Ores and metals?
Your response must be concise. 0.5. What is the difference between the highest and the second highest Amount of imports(as % of merchandise imports) of Manufactures?
Your answer should be very brief. 0.78. What is the difference between the highest and the second highest Amount of imports(as % of merchandise imports) in Fuel?
Keep it short and to the point. 2.03. What is the difference between the highest and the lowest Amount of imports(as % of merchandise imports) in Ores and metals?
Your response must be concise. 1.72. What is the difference between the highest and the lowest Amount of imports(as % of merchandise imports) in Manufactures?
Provide a succinct answer. 6.01. What is the difference between the highest and the lowest Amount of imports(as % of merchandise imports) in Fuel?
Make the answer very short. 6.45. 